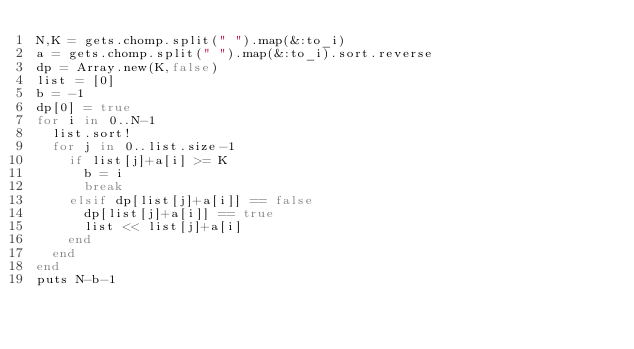Convert code to text. <code><loc_0><loc_0><loc_500><loc_500><_Ruby_>N,K = gets.chomp.split(" ").map(&:to_i)
a = gets.chomp.split(" ").map(&:to_i).sort.reverse
dp = Array.new(K,false)
list = [0]
b = -1
dp[0] = true
for i in 0..N-1
  list.sort!
  for j in 0..list.size-1
    if list[j]+a[i] >= K
      b = i
      break
    elsif dp[list[j]+a[i]] == false
      dp[list[j]+a[i]] == true
      list << list[j]+a[i]
    end
  end
end
puts N-b-1</code> 